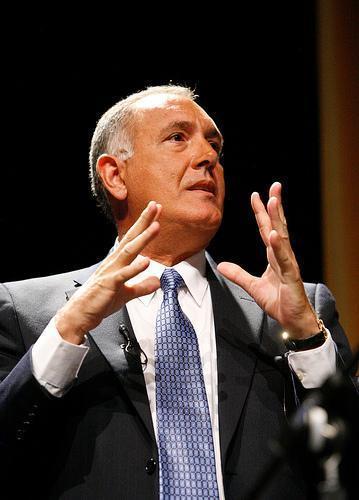How many men?
Give a very brief answer. 1. 